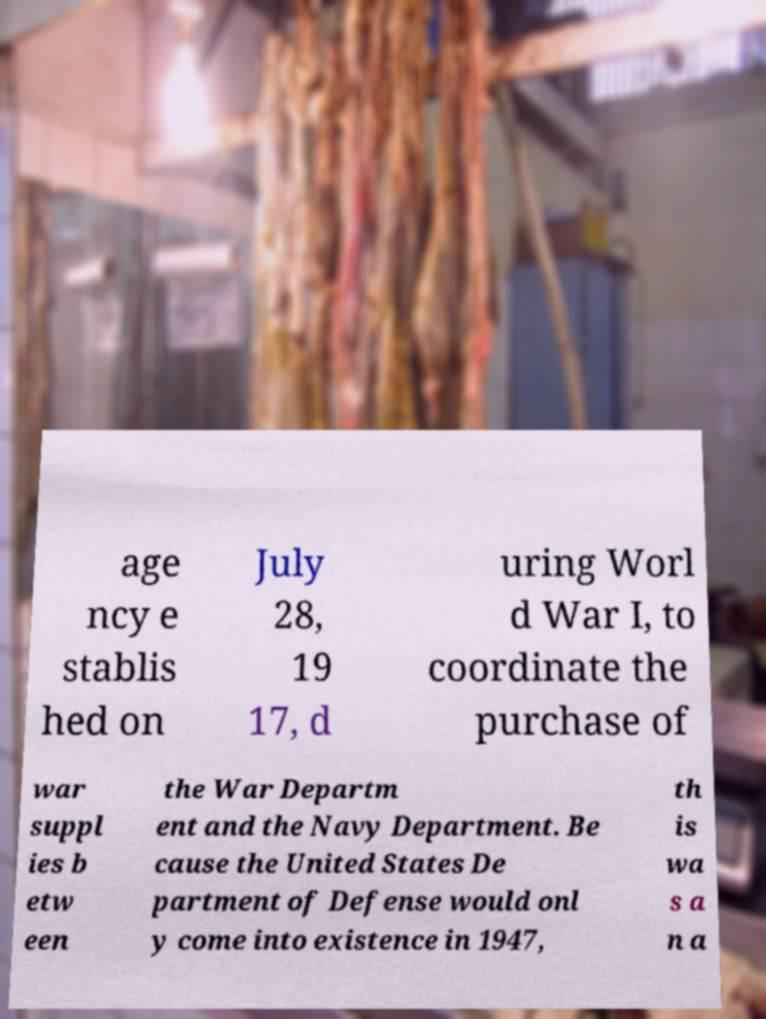For documentation purposes, I need the text within this image transcribed. Could you provide that? age ncy e stablis hed on July 28, 19 17, d uring Worl d War I, to coordinate the purchase of war suppl ies b etw een the War Departm ent and the Navy Department. Be cause the United States De partment of Defense would onl y come into existence in 1947, th is wa s a n a 